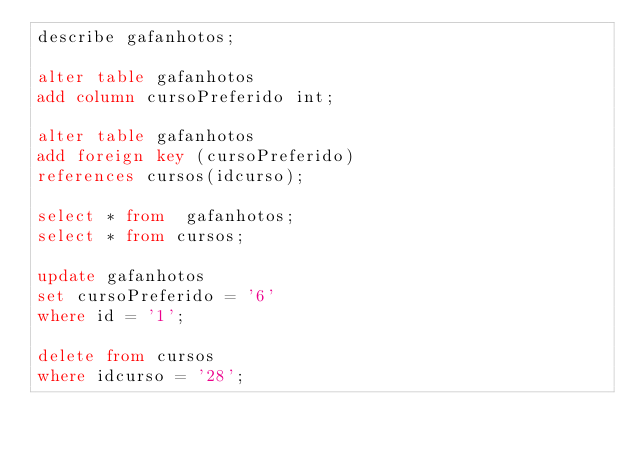<code> <loc_0><loc_0><loc_500><loc_500><_SQL_>describe gafanhotos;

alter table gafanhotos
add column cursoPreferido int;

alter table gafanhotos
add foreign key (cursoPreferido)
references cursos(idcurso);

select * from  gafanhotos;
select * from cursos;

update gafanhotos
set cursoPreferido = '6'
where id = '1';

delete from cursos
where idcurso = '28';</code> 